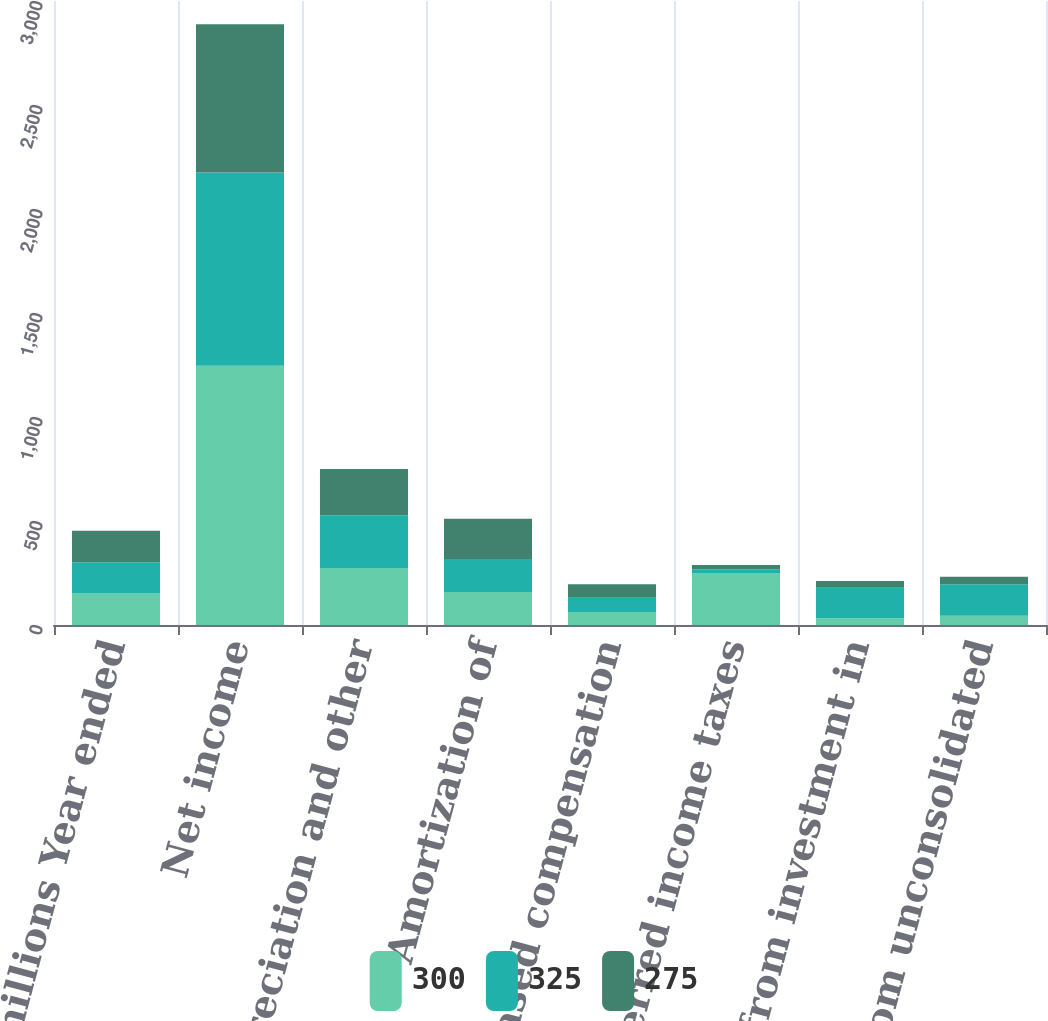Convert chart. <chart><loc_0><loc_0><loc_500><loc_500><stacked_bar_chart><ecel><fcel>In millions Year ended<fcel>Net income<fcel>Depreciation and other<fcel>Amortization of<fcel>Share-based compensation<fcel>Deferred income taxes<fcel>Income from investment in<fcel>Dividends from unconsolidated<nl><fcel>300<fcel>151<fcel>1246<fcel>274<fcel>159<fcel>63<fcel>247<fcel>32<fcel>45<nl><fcel>325<fcel>151<fcel>930<fcel>253<fcel>158<fcel>68<fcel>21<fcel>147<fcel>151<nl><fcel>275<fcel>151<fcel>712<fcel>223<fcel>194<fcel>65<fcel>20<fcel>32<fcel>36<nl></chart> 